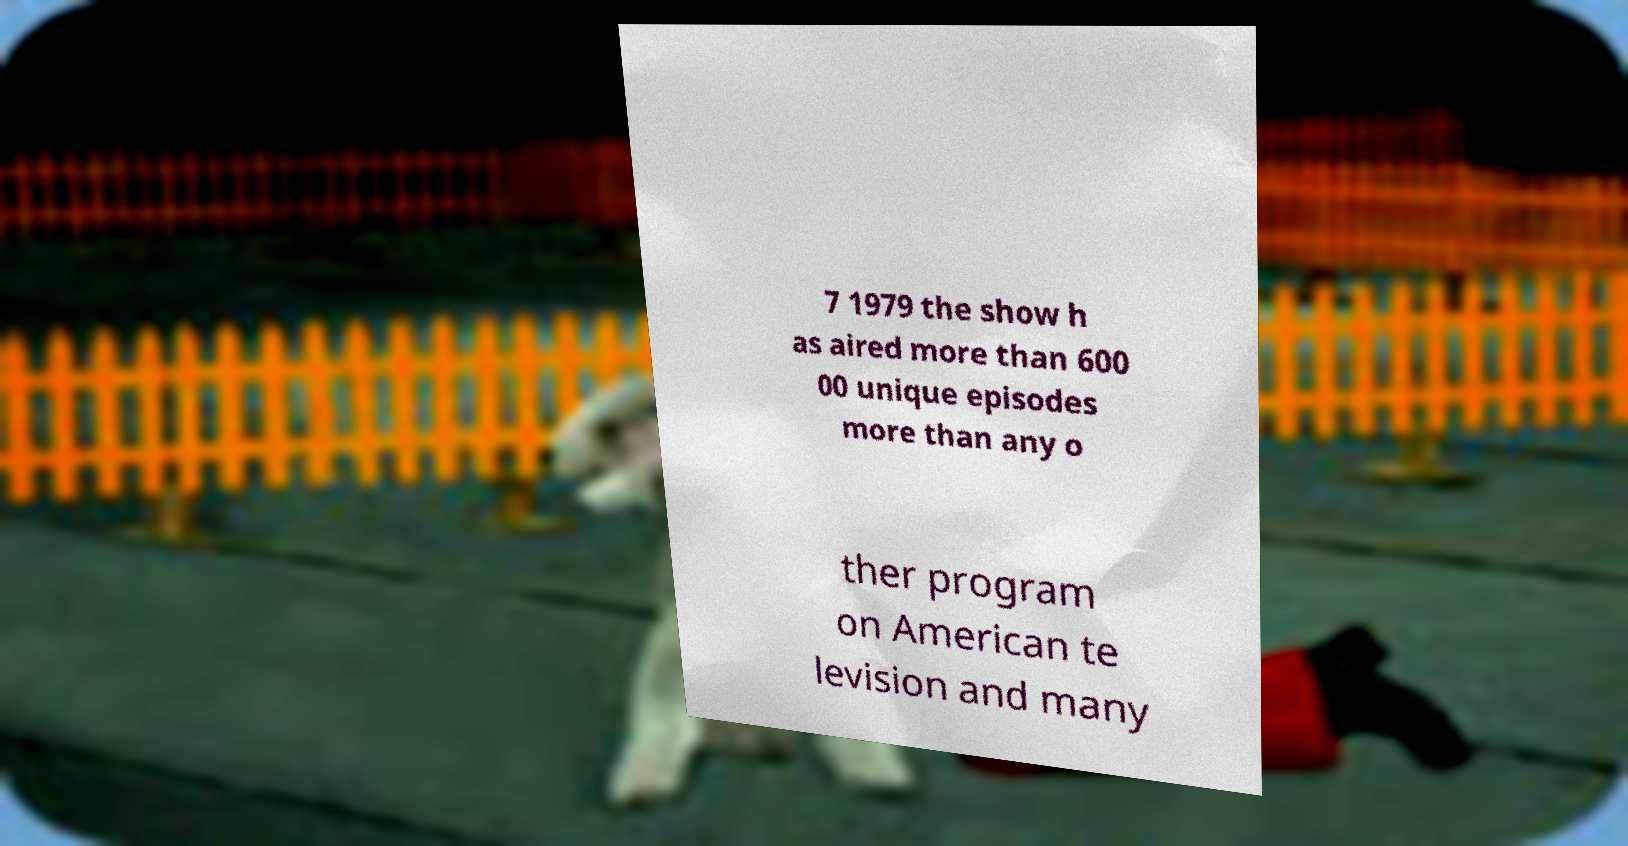There's text embedded in this image that I need extracted. Can you transcribe it verbatim? 7 1979 the show h as aired more than 600 00 unique episodes more than any o ther program on American te levision and many 